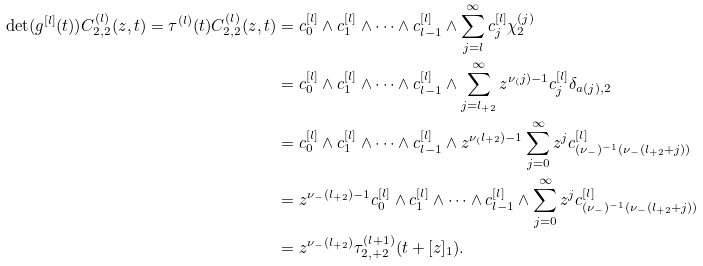<formula> <loc_0><loc_0><loc_500><loc_500>\det ( g ^ { [ l ] } ( t ) ) C _ { 2 , 2 } ^ { ( l ) } ( z , t ) = \tau ^ { ( l ) } ( t ) C _ { 2 , 2 } ^ { ( l ) } ( z , t ) & = c _ { 0 } ^ { [ l ] } \wedge c _ { 1 } ^ { [ l ] } \wedge \dots \wedge c _ { l - 1 } ^ { [ l ] } \wedge \sum _ { j = l } ^ { \infty } c _ { j } ^ { [ l ] } \chi _ { 2 } ^ { ( j ) } \\ & = c _ { 0 } ^ { [ l ] } \wedge c _ { 1 } ^ { [ l ] } \wedge \dots \wedge c _ { l - 1 } ^ { [ l ] } \wedge \sum _ { j = l _ { + 2 } } ^ { \infty } z ^ { \nu _ { ( } j ) - 1 } c _ { j } ^ { [ l ] } \delta _ { a ( j ) , 2 } \\ & = c _ { 0 } ^ { [ l ] } \wedge c _ { 1 } ^ { [ l ] } \wedge \dots \wedge c _ { l - 1 } ^ { [ l ] } \wedge z ^ { \nu _ { ( } l _ { + 2 } ) - 1 } \sum _ { j = 0 } ^ { \infty } z ^ { j } c _ { ( \nu _ { - } ) ^ { - 1 } ( \nu _ { - } ( l _ { + 2 } + j ) ) } ^ { [ l ] } \\ & = z ^ { \nu _ { - } ( l _ { + 2 } ) - 1 } c _ { 0 } ^ { [ l ] } \wedge c _ { 1 } ^ { [ l ] } \wedge \dots \wedge c _ { l - 1 } ^ { [ l ] } \wedge \sum _ { j = 0 } ^ { \infty } z ^ { j } c _ { ( \nu _ { - } ) ^ { - 1 } ( \nu _ { - } ( l _ { + 2 } + j ) ) } ^ { [ l ] } \\ & = z ^ { \nu _ { - } ( l _ { + 2 } ) } \tau _ { 2 , + 2 } ^ { ( l + 1 ) } ( t + [ z ] _ { 1 } ) .</formula> 